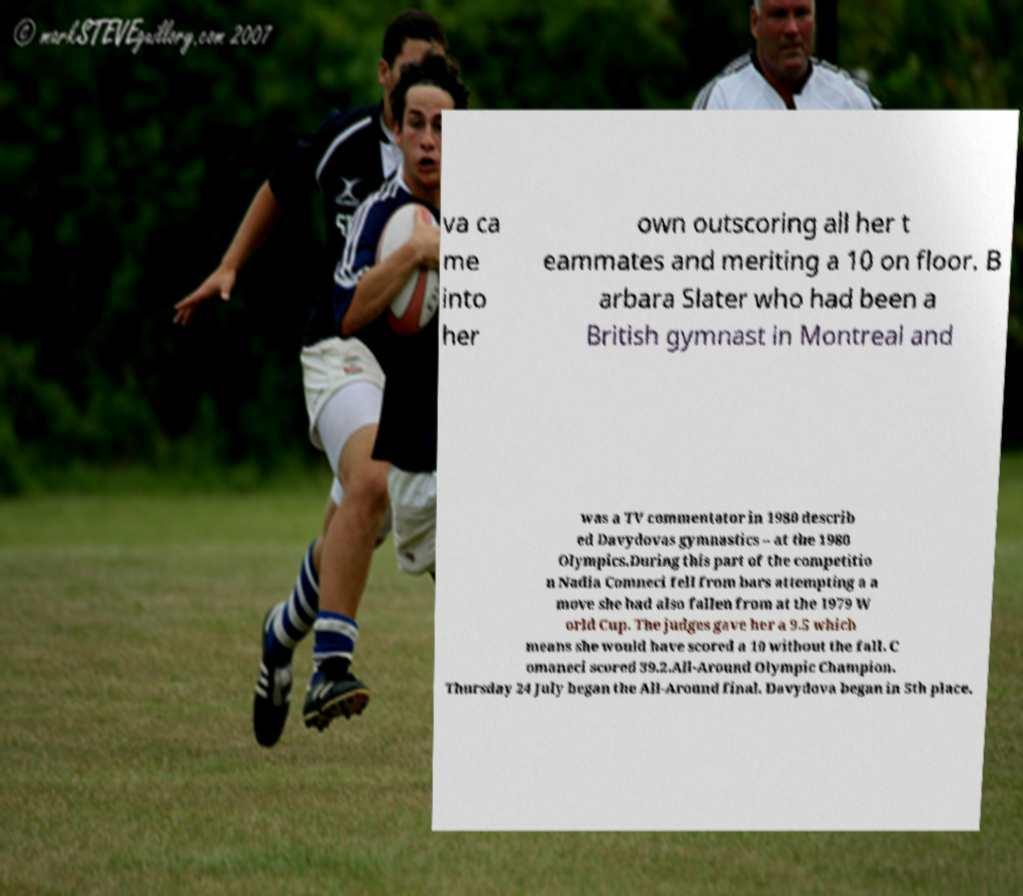Could you extract and type out the text from this image? va ca me into her own outscoring all her t eammates and meriting a 10 on floor. B arbara Slater who had been a British gymnast in Montreal and was a TV commentator in 1980 describ ed Davydovas gymnastics – at the 1980 Olympics.During this part of the competitio n Nadia Comneci fell from bars attempting a a move she had also fallen from at the 1979 W orld Cup. The judges gave her a 9.5 which means she would have scored a 10 without the fall. C omaneci scored 39.2.All-Around Olympic Champion. Thursday 24 July began the All-Around final. Davydova began in 5th place. 